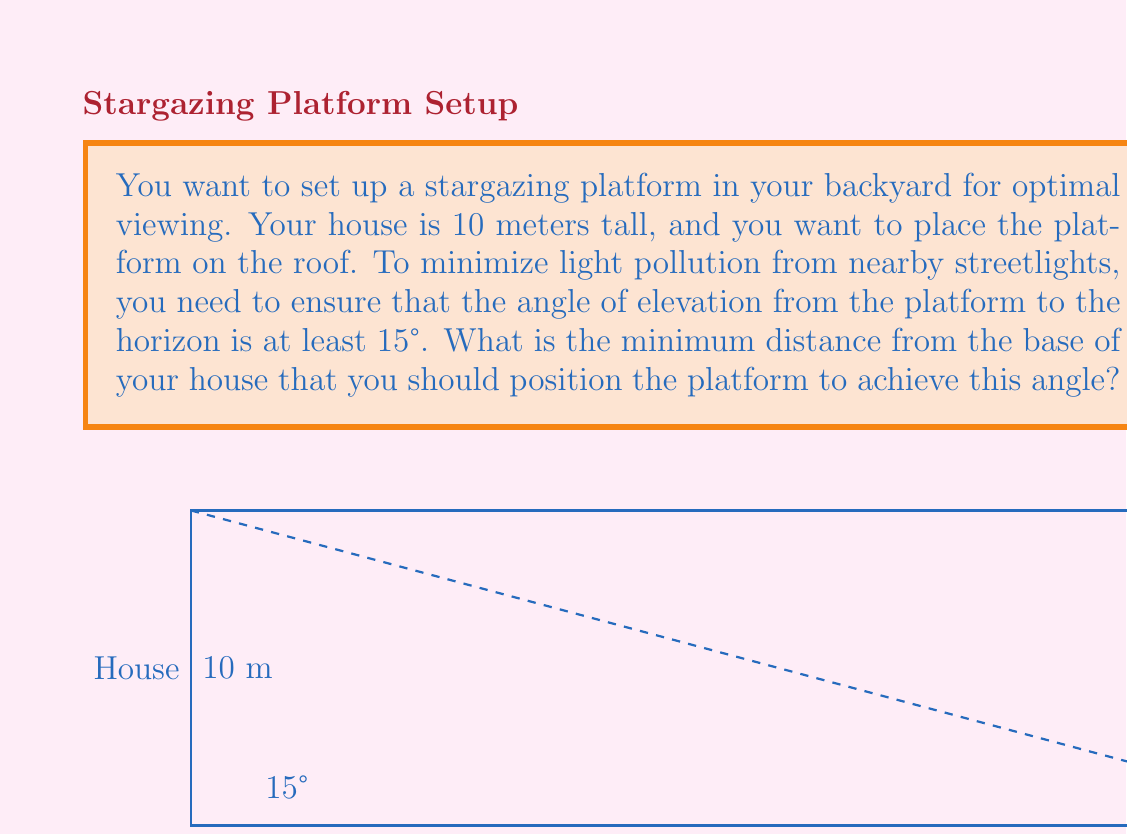Give your solution to this math problem. Let's approach this step-by-step:

1) We can model this situation as a right triangle, where:
   - The vertical side is the height of the house (10 meters)
   - The horizontal side is the distance we're trying to find
   - The angle at the base is 15° (the minimum angle of elevation)

2) In this right triangle, we know:
   - The opposite side (height of the house) = 10 meters
   - The angle at the base = 15°

3) We need to find the adjacent side (the distance from the base of the house).

4) We can use the tangent function for this:

   $$\tan(\theta) = \frac{\text{opposite}}{\text{adjacent}}$$

5) Plugging in our known values:

   $$\tan(15°) = \frac{10}{\text{distance}}$$

6) To solve for the distance, we rearrange the equation:

   $$\text{distance} = \frac{10}{\tan(15°)}$$

7) Now we can calculate:
   
   $$\text{distance} = \frac{10}{\tan(15°)} \approx 37.3 \text{ meters}$$

Therefore, the platform should be positioned at least 37.3 meters from the base of the house to achieve an angle of elevation of 15°.
Answer: The minimum distance from the base of the house to position the platform is approximately 37.3 meters. 